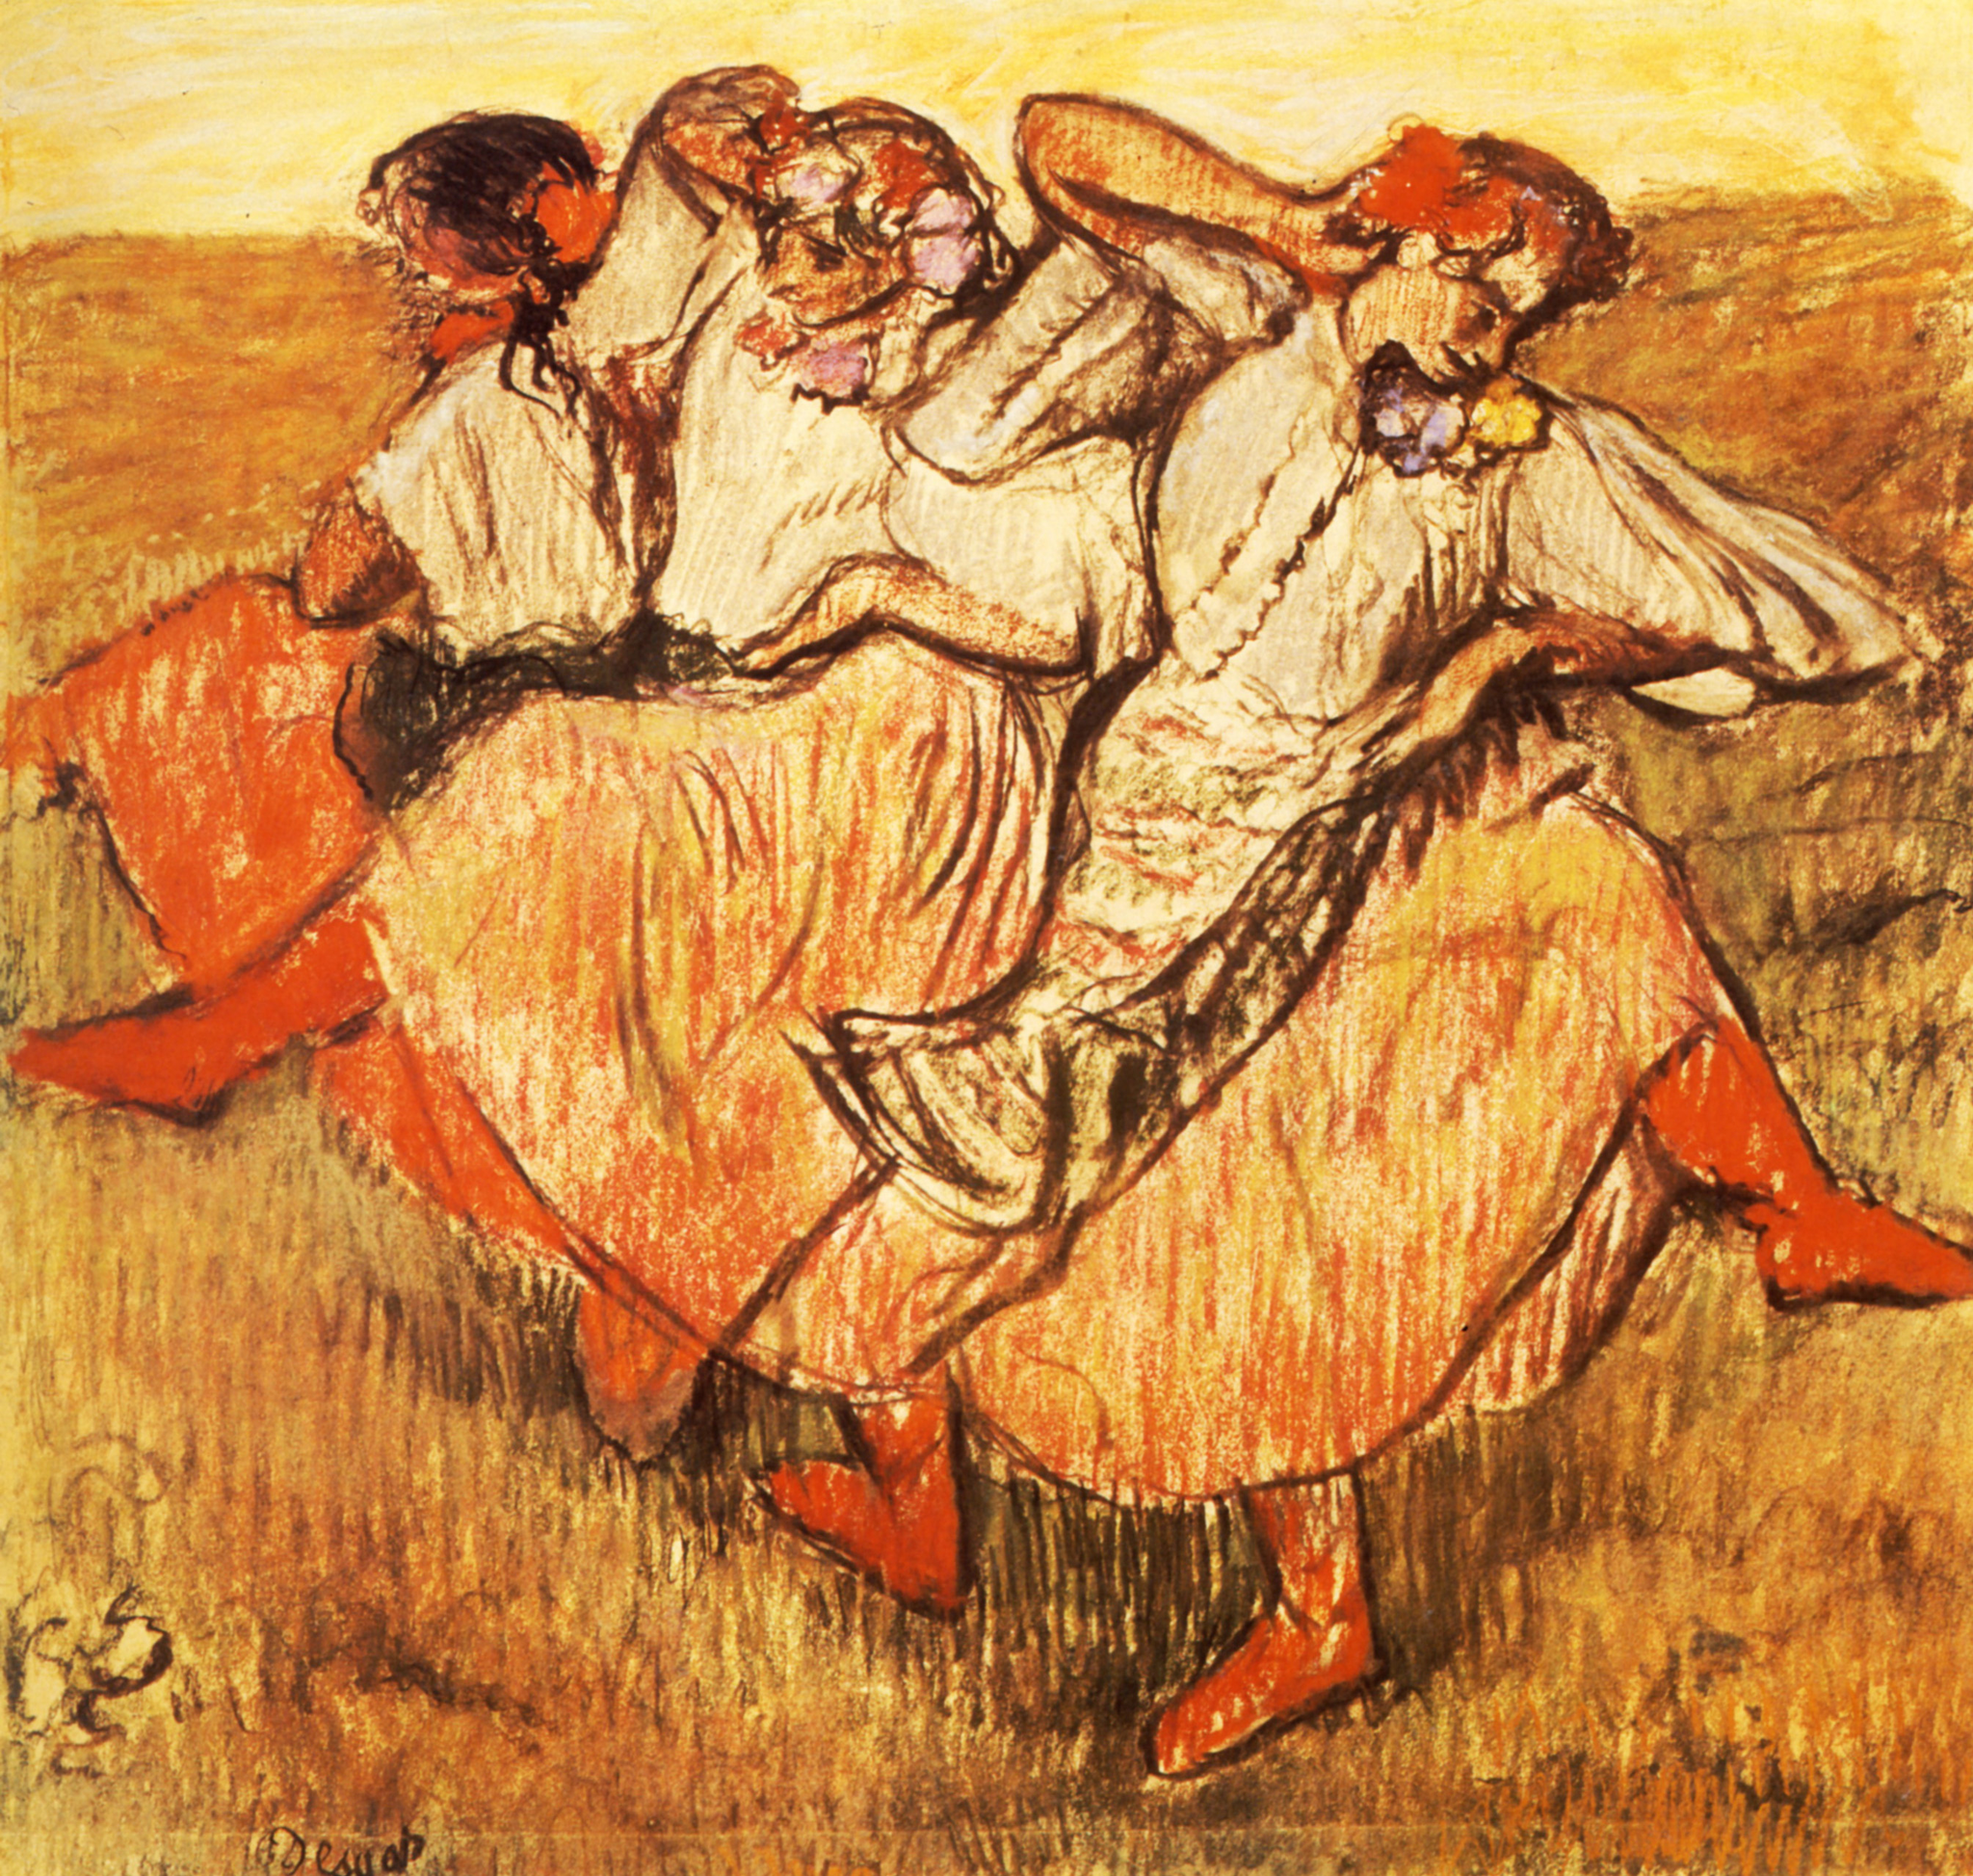Describe the following image. The image depicts an expressive, impressionist-style artwork showcasing a trio of women engaged in a lively dance. Each woman is dressed in a long, flowing dress, with hues of orange and white that suggest vivacity and movement. As is characteristic of impressionism, the painting employs loose, energized brushstrokes that evoke the dynamic motion of the dance. The background suggests a pastoral setting with a warm, golden ambiance that might indicate late afternoon sunlight casting over a meadow. This piece vividly captures the essence of joy and freedom evident in the dancers’ carefree movements, reflecting the impressionists' fascination with light, color, and capturing the moment. 